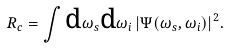Convert formula to latex. <formula><loc_0><loc_0><loc_500><loc_500>R _ { c } = \int \text {d} \omega _ { s } \text {d} \omega _ { i } \, | \Psi ( \omega _ { s } , \omega _ { i } ) | ^ { 2 } .</formula> 